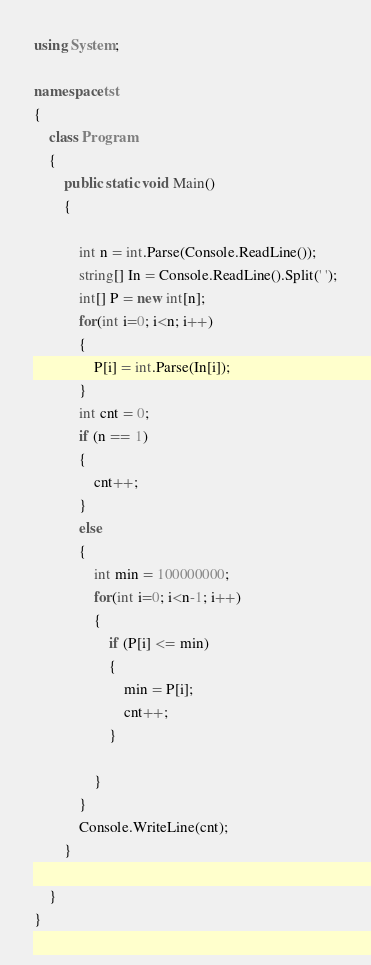Convert code to text. <code><loc_0><loc_0><loc_500><loc_500><_C#_>using System;

namespace tst
{
    class Program
    {
        public static void Main()
        {

            int n = int.Parse(Console.ReadLine());
            string[] In = Console.ReadLine().Split(' ');
            int[] P = new int[n];
            for(int i=0; i<n; i++)
            {
                P[i] = int.Parse(In[i]);
            }
            int cnt = 0;
            if (n == 1)
            {
                cnt++;
            }
            else
            {
                int min = 100000000;
                for(int i=0; i<n-1; i++)
                {
                    if (P[i] <= min)
                    {
                        min = P[i];
                        cnt++;
                    }

                }
            }
            Console.WriteLine(cnt);
        }

    }
}</code> 